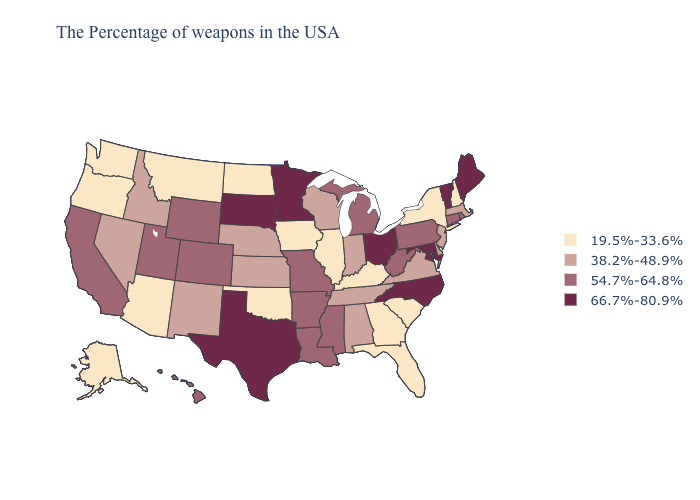Which states have the highest value in the USA?
Write a very short answer. Maine, Vermont, Maryland, North Carolina, Ohio, Minnesota, Texas, South Dakota. Does New Mexico have a higher value than Wyoming?
Keep it brief. No. What is the value of Oklahoma?
Keep it brief. 19.5%-33.6%. Does North Dakota have the highest value in the USA?
Answer briefly. No. Name the states that have a value in the range 19.5%-33.6%?
Short answer required. New Hampshire, New York, South Carolina, Florida, Georgia, Kentucky, Illinois, Iowa, Oklahoma, North Dakota, Montana, Arizona, Washington, Oregon, Alaska. What is the value of Washington?
Write a very short answer. 19.5%-33.6%. Among the states that border Minnesota , which have the lowest value?
Write a very short answer. Iowa, North Dakota. Name the states that have a value in the range 66.7%-80.9%?
Short answer required. Maine, Vermont, Maryland, North Carolina, Ohio, Minnesota, Texas, South Dakota. What is the value of Illinois?
Be succinct. 19.5%-33.6%. Name the states that have a value in the range 38.2%-48.9%?
Short answer required. Massachusetts, New Jersey, Delaware, Virginia, Indiana, Alabama, Tennessee, Wisconsin, Kansas, Nebraska, New Mexico, Idaho, Nevada. What is the highest value in the USA?
Quick response, please. 66.7%-80.9%. What is the value of Texas?
Quick response, please. 66.7%-80.9%. Does the first symbol in the legend represent the smallest category?
Give a very brief answer. Yes. Does Alabama have a lower value than Utah?
Be succinct. Yes. What is the value of New York?
Quick response, please. 19.5%-33.6%. 